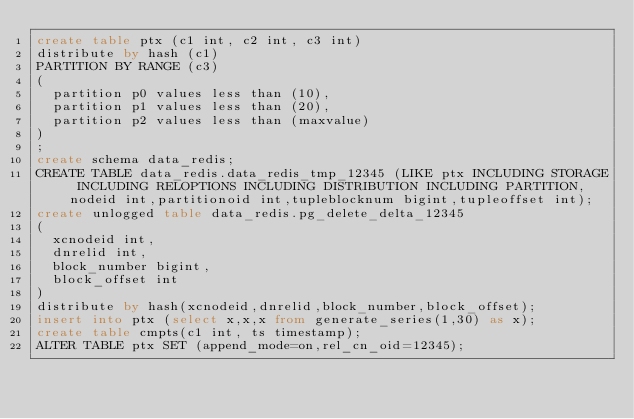Convert code to text. <code><loc_0><loc_0><loc_500><loc_500><_SQL_>create table ptx (c1 int, c2 int, c3 int) 
distribute by hash (c1) 
PARTITION BY RANGE (c3)
(
	partition p0 values less than (10),
	partition p1 values less than (20),
	partition p2 values less than (maxvalue)
)
;
create schema data_redis;
CREATE TABLE data_redis.data_redis_tmp_12345 (LIKE ptx INCLUDING STORAGE INCLUDING RELOPTIONS INCLUDING DISTRIBUTION INCLUDING PARTITION, nodeid int,partitionoid int,tupleblocknum bigint,tupleoffset int);
create unlogged table data_redis.pg_delete_delta_12345
(
	xcnodeid int,
	dnrelid int,
	block_number bigint,
	block_offset int
)
distribute by hash(xcnodeid,dnrelid,block_number,block_offset);
insert into ptx (select x,x,x from generate_series(1,30) as x);
create table cmpts(c1 int, ts timestamp);
ALTER TABLE ptx SET (append_mode=on,rel_cn_oid=12345);
</code> 